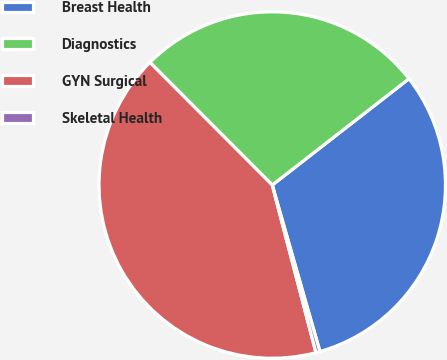Convert chart to OTSL. <chart><loc_0><loc_0><loc_500><loc_500><pie_chart><fcel>Breast Health<fcel>Diagnostics<fcel>GYN Surgical<fcel>Skeletal Health<nl><fcel>31.08%<fcel>26.96%<fcel>41.58%<fcel>0.38%<nl></chart> 